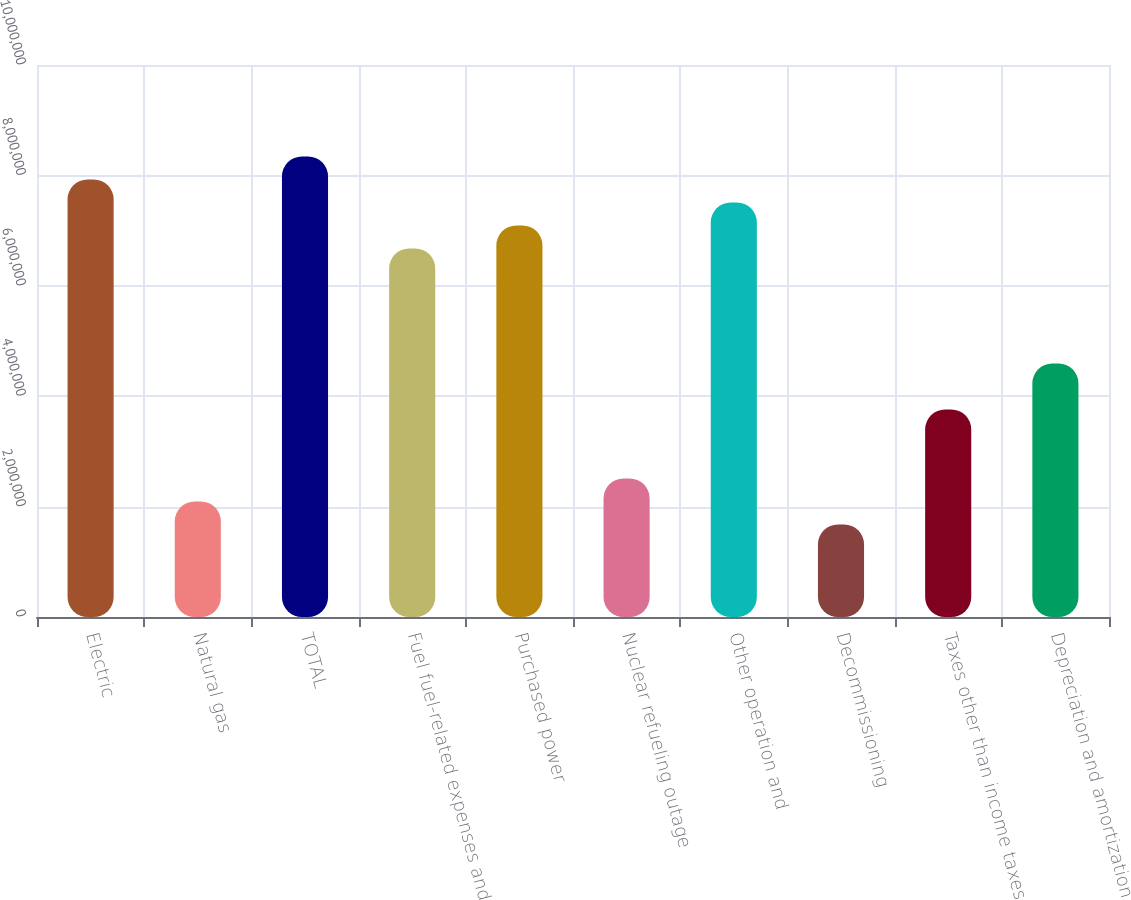Convert chart. <chart><loc_0><loc_0><loc_500><loc_500><bar_chart><fcel>Electric<fcel>Natural gas<fcel>TOTAL<fcel>Fuel fuel-related expenses and<fcel>Purchased power<fcel>Nuclear refueling outage<fcel>Other operation and<fcel>Decommissioning<fcel>Taxes other than income taxes<fcel>Depreciation and amortization<nl><fcel>7.92595e+06<fcel>2.09432e+06<fcel>8.3425e+06<fcel>6.67632e+06<fcel>7.09286e+06<fcel>2.51087e+06<fcel>7.50941e+06<fcel>1.67778e+06<fcel>3.7605e+06<fcel>4.59359e+06<nl></chart> 